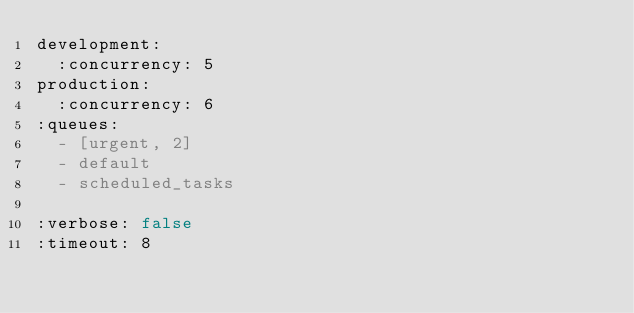Convert code to text. <code><loc_0><loc_0><loc_500><loc_500><_YAML_>development:
  :concurrency: 5
production:
  :concurrency: 6
:queues:
  - [urgent, 2]
  - default
  - scheduled_tasks

:verbose: false
:timeout: 8
</code> 